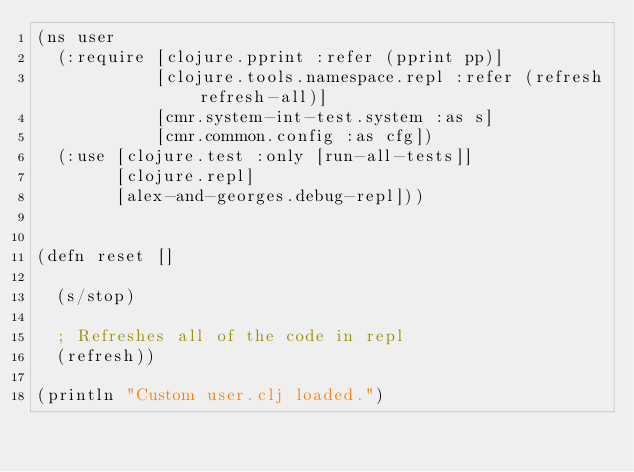Convert code to text. <code><loc_0><loc_0><loc_500><loc_500><_Clojure_>(ns user
  (:require [clojure.pprint :refer (pprint pp)]
            [clojure.tools.namespace.repl :refer (refresh refresh-all)]
            [cmr.system-int-test.system :as s]
            [cmr.common.config :as cfg])
  (:use [clojure.test :only [run-all-tests]]
        [clojure.repl]
        [alex-and-georges.debug-repl]))


(defn reset []

  (s/stop)

  ; Refreshes all of the code in repl
  (refresh))

(println "Custom user.clj loaded.")
</code> 